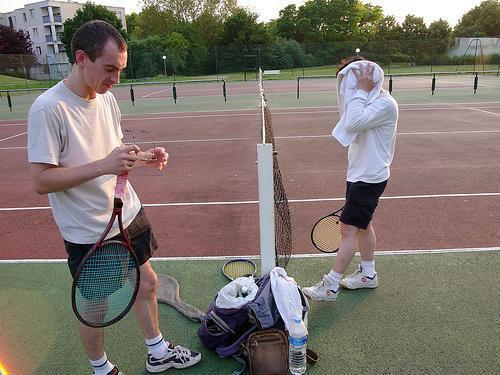How many people are there?
Give a very brief answer. 2. How many tennis rackets are there?
Give a very brief answer. 1. How many open umbrellas are there?
Give a very brief answer. 0. 